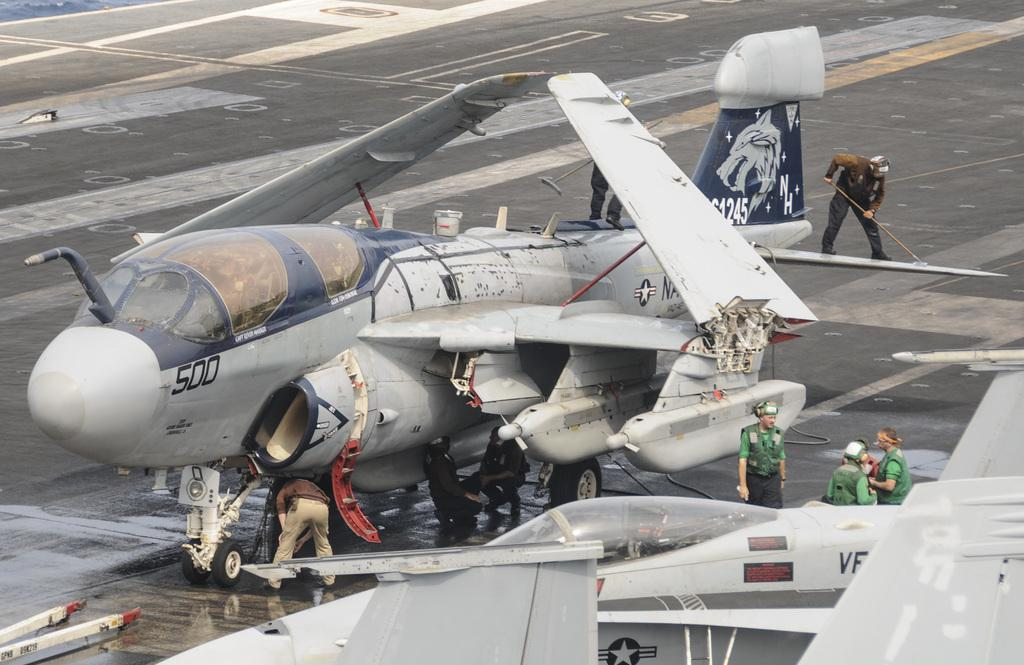Who is present in the image? There are people in the image. What is one person holding in the image? There is a person holding a wiper in the image. What type of vehicles can be seen in the image? Airplanes are visible on the surface in the image. What type of pies is the dad making in the image? There is no dad or pies present in the image. How many horses are pulling the carriage in the image? There is no carriage present in the image. 